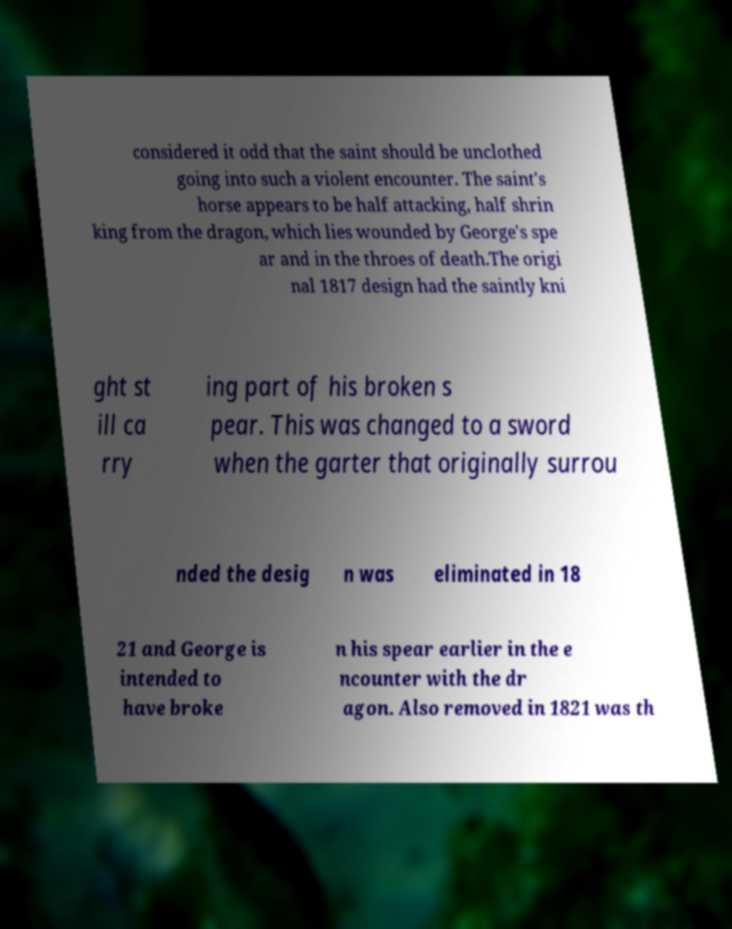Please identify and transcribe the text found in this image. considered it odd that the saint should be unclothed going into such a violent encounter. The saint's horse appears to be half attacking, half shrin king from the dragon, which lies wounded by George's spe ar and in the throes of death.The origi nal 1817 design had the saintly kni ght st ill ca rry ing part of his broken s pear. This was changed to a sword when the garter that originally surrou nded the desig n was eliminated in 18 21 and George is intended to have broke n his spear earlier in the e ncounter with the dr agon. Also removed in 1821 was th 